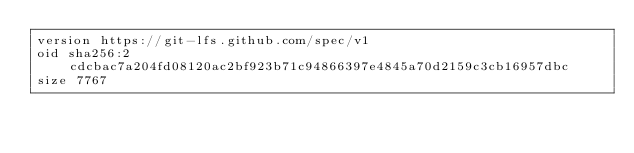Convert code to text. <code><loc_0><loc_0><loc_500><loc_500><_HTML_>version https://git-lfs.github.com/spec/v1
oid sha256:2cdcbac7a204fd08120ac2bf923b71c94866397e4845a70d2159c3cb16957dbc
size 7767
</code> 